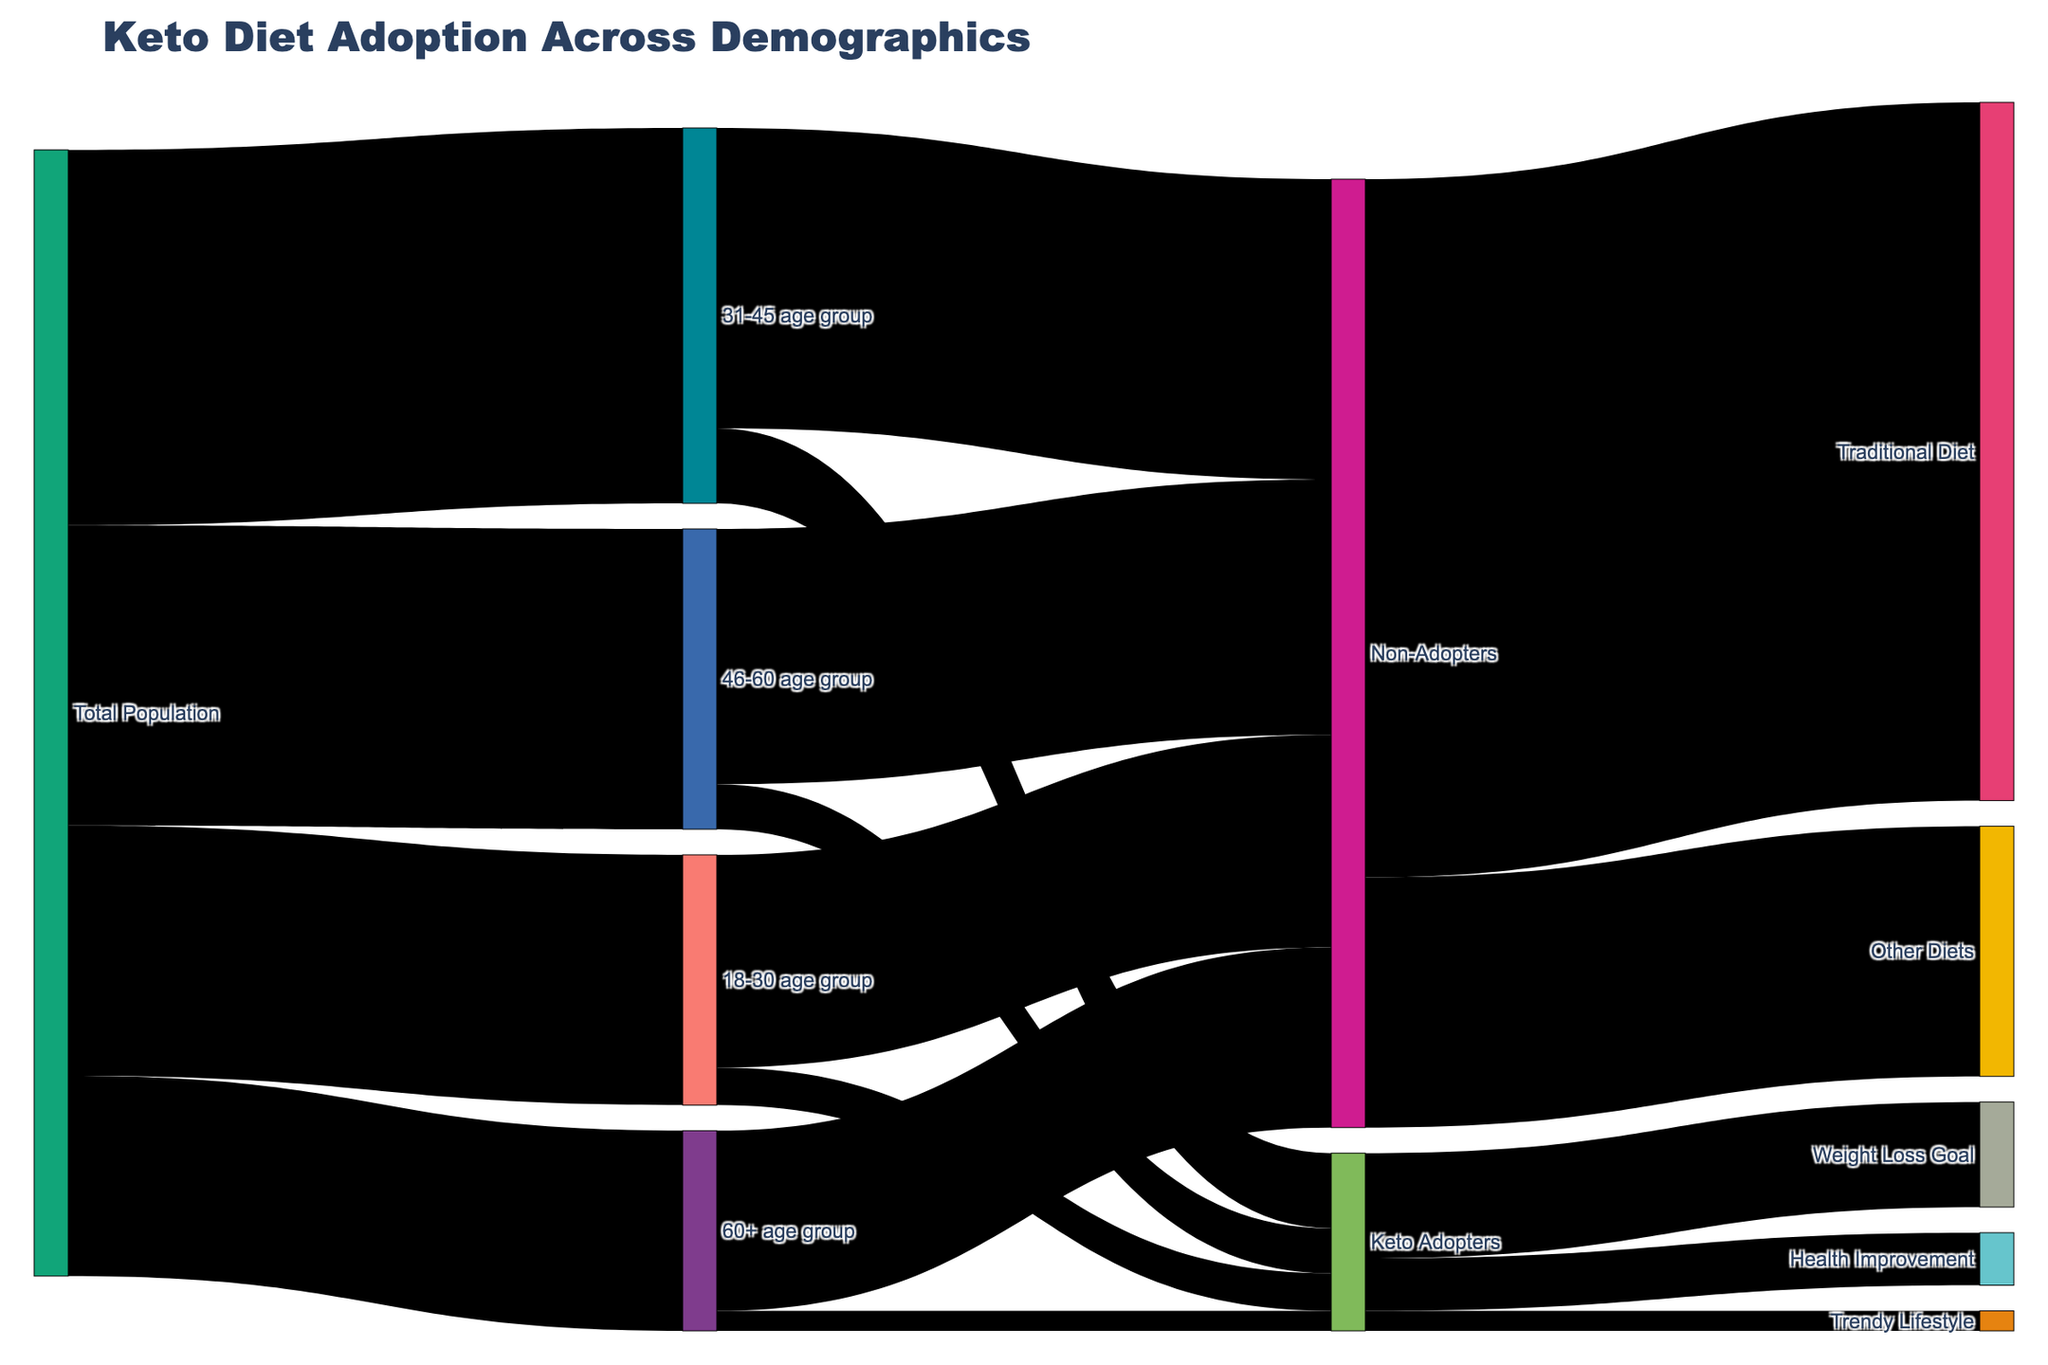How many total people are in the 31-45 age group? Look for the connecting link from "Total Population" to "31-45 age group" to find the value, which is 1,500,000.
Answer: 1,500,000 Which age group has the highest number of keto adopters? Compare the values of keto adopters across different age groups. The "31-45 age group" has 300,000 keto adopters, the highest among the groups.
Answer: 31-45 age group How many more keto adopters are there in the 31-45 age group compared to the 18-30 age group? Subtract the number of adopters in the 18-30 age group (150,000) from the 31-45 age group (300,000): 300,000 - 150,000 = 150,000.
Answer: 150,000 What is the total number of keto adopters across all age groups? Sum the values of keto adopters from all age groups: 150,000 (18-30) + 300,000 (31-45) + 180,000 (46-60) + 80,000 (60+).
Answer: 710,000 Which demographic has the least number of people following a traditional diet? Compare the values of non-adopters in each age group and their distribution. The "60+ age group" has the least with 720,000.
Answer: 60+ age group What is the main reason people adopt the keto diet according to the diagram? Compare the links from "Keto Adopters" to different goals. The "Weight Loss Goal" has the highest connection value of 420,000.
Answer: Weight Loss Goal How many people aged 60+ do not follow the keto diet? Look for the link connecting "60+ age group" to "Non-Adopters", which shows 720,000 people.
Answer: 720,000 Between the "Weight Loss Goal" and "Health Improvement", which one has more adopters and by how much? Compare the values: Weight Loss Goal (420,000) and Health Improvement (210,000). Subtract to find the difference: 420,000 - 210,000 = 210,000.
Answer: Weight Loss Goal by 210,000 What's the proportion of keto adopters to non-adopters in the 46-60 age group? 180,000 keto adopters compared to 1,020,000 non-adopters, so the proportion is 180,000 / 1,200,000 = 0.15.
Answer: 0.15 What percentage of the total population are keto adopters aiming for a trendy lifestyle? Divide the number of adopters with a trendy lifestyle goal (80,000) by the total population (4,400,000) and multiply by 100: (80,000 / 4,400,000) * 100 = 1.82%.
Answer: 1.82% 